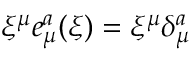Convert formula to latex. <formula><loc_0><loc_0><loc_500><loc_500>\xi ^ { \mu } e _ { \mu } ^ { a } ( \xi ) = \xi ^ { \mu } \delta _ { \mu } ^ { a }</formula> 